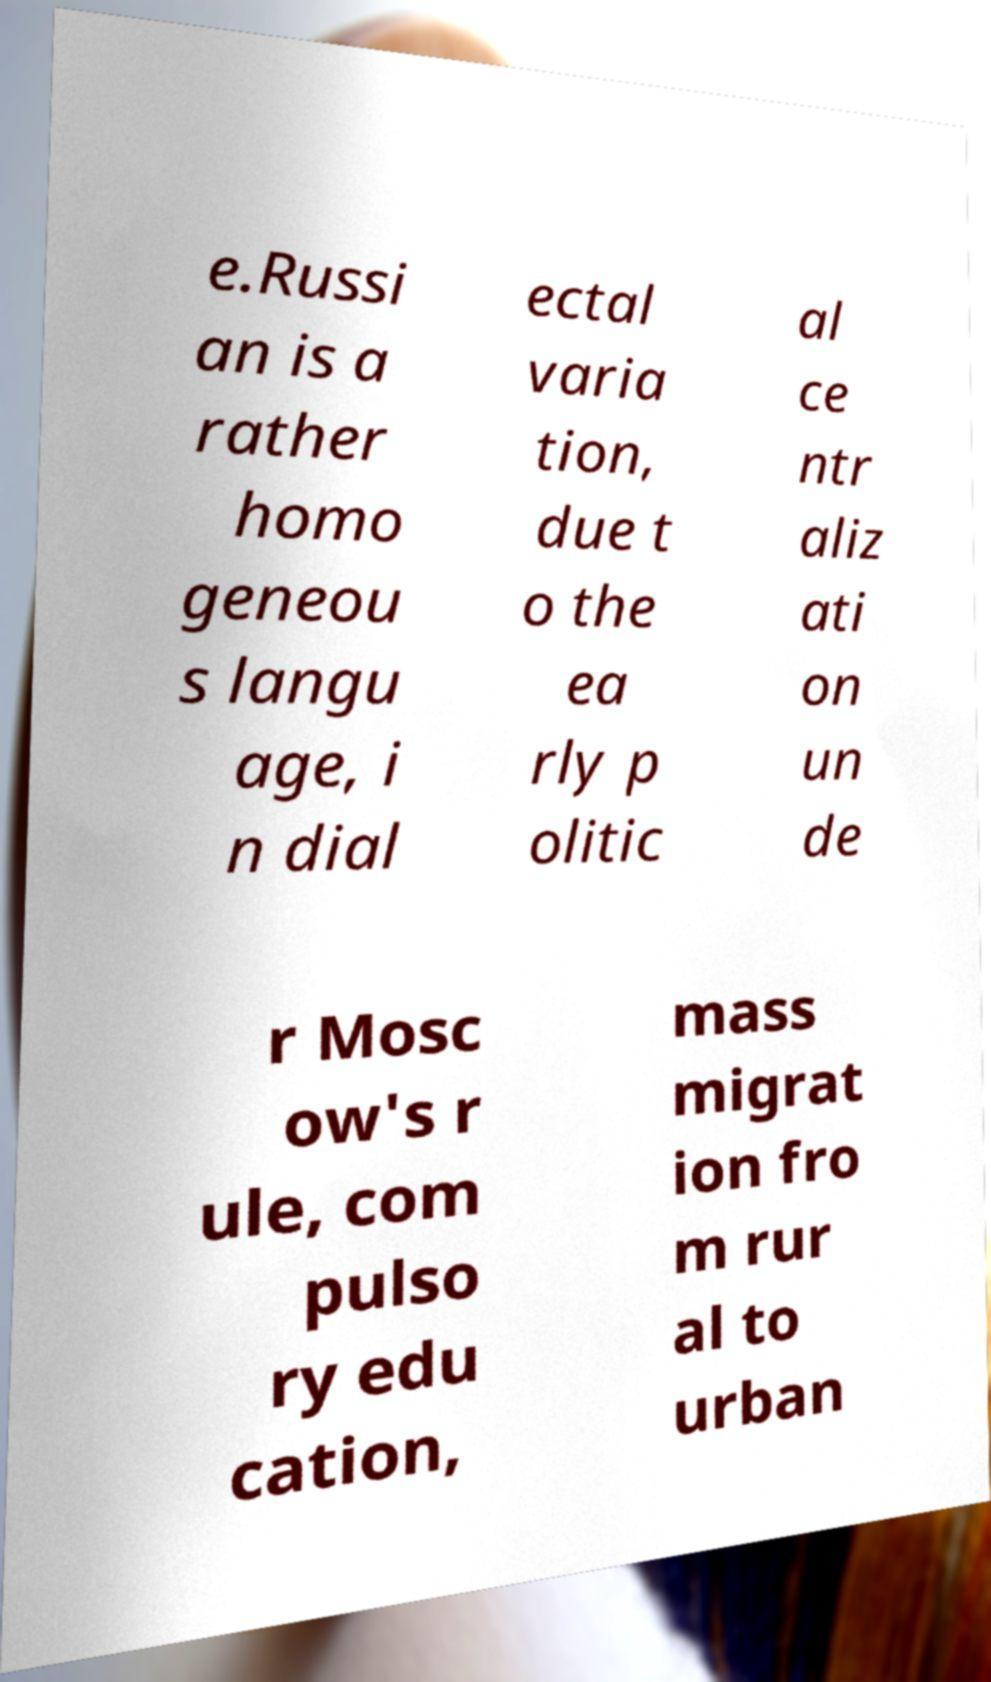I need the written content from this picture converted into text. Can you do that? e.Russi an is a rather homo geneou s langu age, i n dial ectal varia tion, due t o the ea rly p olitic al ce ntr aliz ati on un de r Mosc ow's r ule, com pulso ry edu cation, mass migrat ion fro m rur al to urban 